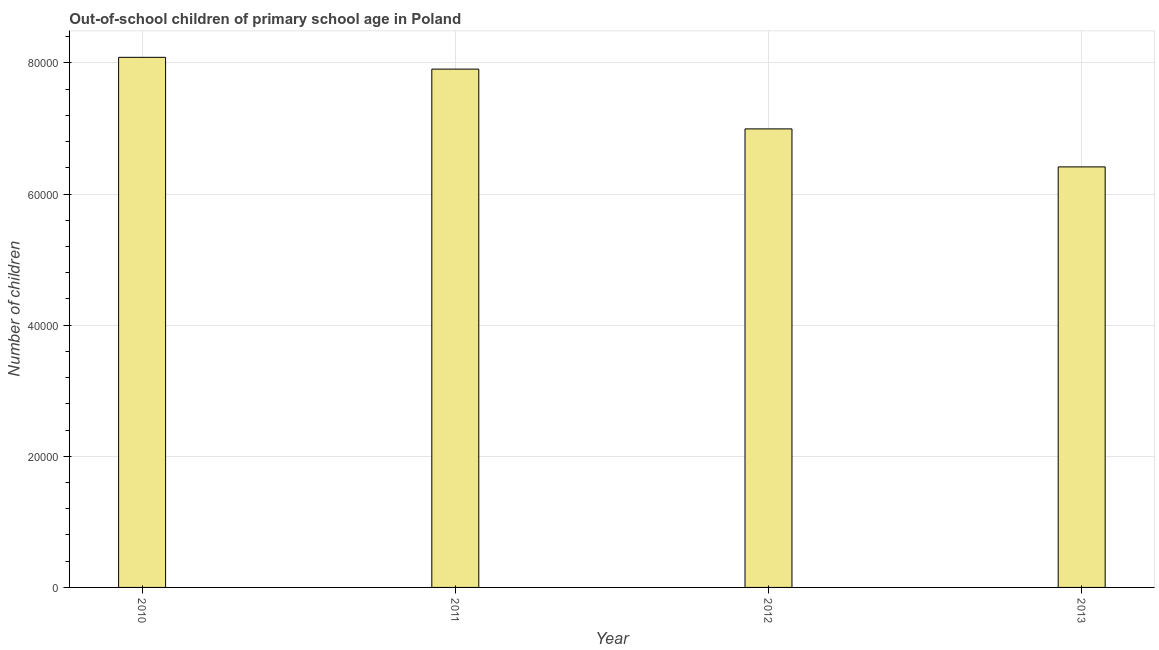Does the graph contain any zero values?
Your answer should be very brief. No. What is the title of the graph?
Make the answer very short. Out-of-school children of primary school age in Poland. What is the label or title of the X-axis?
Offer a very short reply. Year. What is the label or title of the Y-axis?
Provide a succinct answer. Number of children. What is the number of out-of-school children in 2012?
Your answer should be compact. 6.99e+04. Across all years, what is the maximum number of out-of-school children?
Provide a short and direct response. 8.09e+04. Across all years, what is the minimum number of out-of-school children?
Make the answer very short. 6.41e+04. In which year was the number of out-of-school children minimum?
Make the answer very short. 2013. What is the sum of the number of out-of-school children?
Offer a terse response. 2.94e+05. What is the difference between the number of out-of-school children in 2012 and 2013?
Keep it short and to the point. 5798. What is the average number of out-of-school children per year?
Your answer should be very brief. 7.35e+04. What is the median number of out-of-school children?
Ensure brevity in your answer.  7.45e+04. In how many years, is the number of out-of-school children greater than 44000 ?
Keep it short and to the point. 4. Do a majority of the years between 2010 and 2013 (inclusive) have number of out-of-school children greater than 20000 ?
Provide a succinct answer. Yes. What is the ratio of the number of out-of-school children in 2012 to that in 2013?
Ensure brevity in your answer.  1.09. Is the number of out-of-school children in 2011 less than that in 2012?
Offer a terse response. No. Is the difference between the number of out-of-school children in 2010 and 2012 greater than the difference between any two years?
Provide a short and direct response. No. What is the difference between the highest and the second highest number of out-of-school children?
Your response must be concise. 1799. Is the sum of the number of out-of-school children in 2012 and 2013 greater than the maximum number of out-of-school children across all years?
Provide a succinct answer. Yes. What is the difference between the highest and the lowest number of out-of-school children?
Give a very brief answer. 1.67e+04. In how many years, is the number of out-of-school children greater than the average number of out-of-school children taken over all years?
Ensure brevity in your answer.  2. How many bars are there?
Make the answer very short. 4. How many years are there in the graph?
Ensure brevity in your answer.  4. What is the Number of children in 2010?
Your answer should be very brief. 8.09e+04. What is the Number of children of 2011?
Your response must be concise. 7.91e+04. What is the Number of children of 2012?
Offer a very short reply. 6.99e+04. What is the Number of children of 2013?
Keep it short and to the point. 6.41e+04. What is the difference between the Number of children in 2010 and 2011?
Ensure brevity in your answer.  1799. What is the difference between the Number of children in 2010 and 2012?
Offer a very short reply. 1.09e+04. What is the difference between the Number of children in 2010 and 2013?
Your response must be concise. 1.67e+04. What is the difference between the Number of children in 2011 and 2012?
Your response must be concise. 9118. What is the difference between the Number of children in 2011 and 2013?
Provide a succinct answer. 1.49e+04. What is the difference between the Number of children in 2012 and 2013?
Provide a short and direct response. 5798. What is the ratio of the Number of children in 2010 to that in 2011?
Give a very brief answer. 1.02. What is the ratio of the Number of children in 2010 to that in 2012?
Ensure brevity in your answer.  1.16. What is the ratio of the Number of children in 2010 to that in 2013?
Ensure brevity in your answer.  1.26. What is the ratio of the Number of children in 2011 to that in 2012?
Make the answer very short. 1.13. What is the ratio of the Number of children in 2011 to that in 2013?
Provide a short and direct response. 1.23. What is the ratio of the Number of children in 2012 to that in 2013?
Provide a succinct answer. 1.09. 